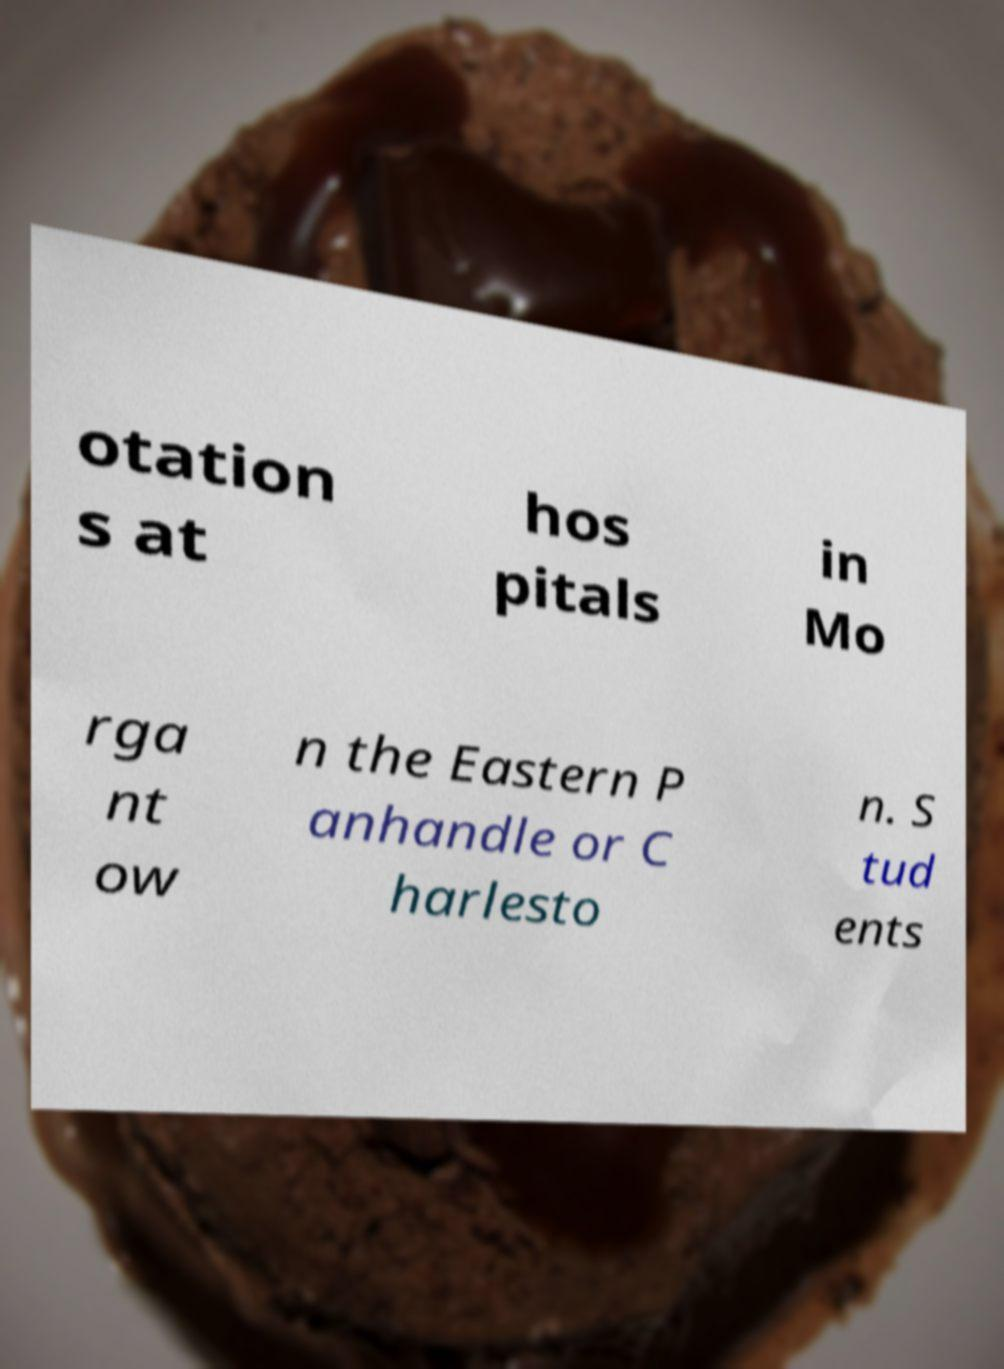Can you accurately transcribe the text from the provided image for me? otation s at hos pitals in Mo rga nt ow n the Eastern P anhandle or C harlesto n. S tud ents 